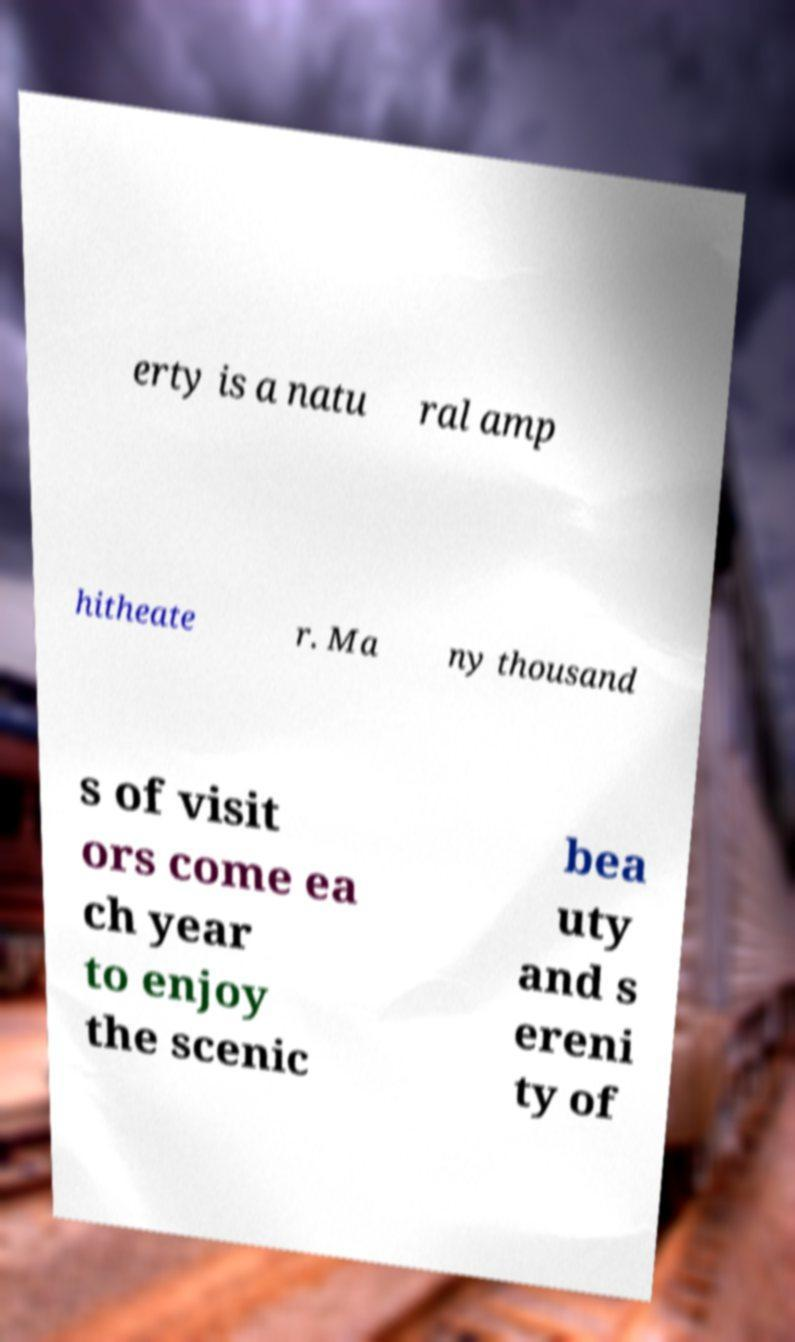For documentation purposes, I need the text within this image transcribed. Could you provide that? erty is a natu ral amp hitheate r. Ma ny thousand s of visit ors come ea ch year to enjoy the scenic bea uty and s ereni ty of 